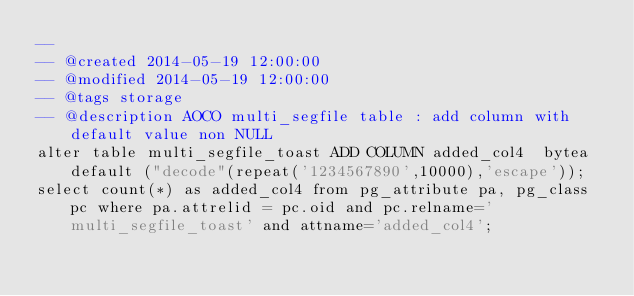<code> <loc_0><loc_0><loc_500><loc_500><_SQL_>-- 
-- @created 2014-05-19 12:00:00
-- @modified 2014-05-19 12:00:00
-- @tags storage
-- @description AOCO multi_segfile table : add column with default value non NULL
alter table multi_segfile_toast ADD COLUMN added_col4  bytea default ("decode"(repeat('1234567890',10000),'escape'));
select count(*) as added_col4 from pg_attribute pa, pg_class pc where pa.attrelid = pc.oid and pc.relname='multi_segfile_toast' and attname='added_col4';
</code> 